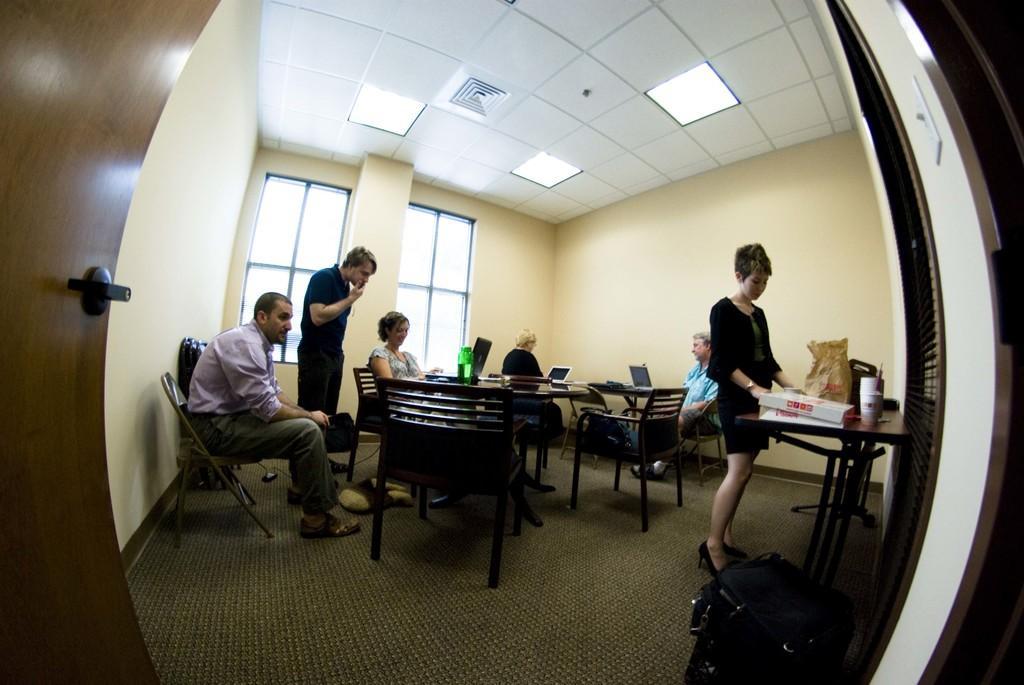Can you describe this image briefly? In this picture i could see the persons sitting on the chairs. There are around six persons in the room. Two of them are standing on the chair sorry standing, one of them is sitting on the chair in the left corner with the purple shirt and a pant there are brown colored chairs and one of the lady in the corner is working on the laptop, she has a black shirt in the room the ceiling is covered with a ac and lights and in the middle of the picture i could see the windows and in the right side there is a wall. In the left corner of the picture i could see the door with the bolt and there is a beautiful carpet on the floor. 